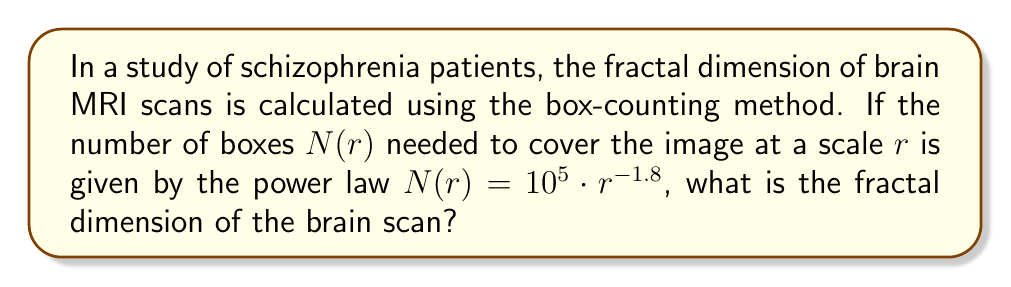Help me with this question. To solve this problem, we'll follow these steps:

1) The box-counting dimension is defined as:

   $$D = \lim_{r \to 0} \frac{\log N(r)}{\log(1/r)}$$

2) In our case, we have $N(r) = 10^5 \cdot r^{-1.8}$

3) Let's substitute this into the formula:

   $$D = \lim_{r \to 0} \frac{\log(10^5 \cdot r^{-1.8})}{\log(1/r)}$$

4) Using the properties of logarithms:

   $$D = \lim_{r \to 0} \frac{\log(10^5) + \log(r^{-1.8})}{\log(1/r)}$$

5) Simplify:

   $$D = \lim_{r \to 0} \frac{\log(10^5) - 1.8\log(r)}{\log(1/r)}$$

6) As $r \to 0$, $\log(10^5)$ becomes negligible compared to $\log(r)$, so:

   $$D = \lim_{r \to 0} \frac{-1.8\log(r)}{\log(1/r)}$$

7) $\log(1/r) = -\log(r)$, so:

   $$D = \lim_{r \to 0} \frac{-1.8\log(r)}{-\log(r)} = 1.8$$

Therefore, the fractal dimension of the brain scan is 1.8.
Answer: 1.8 